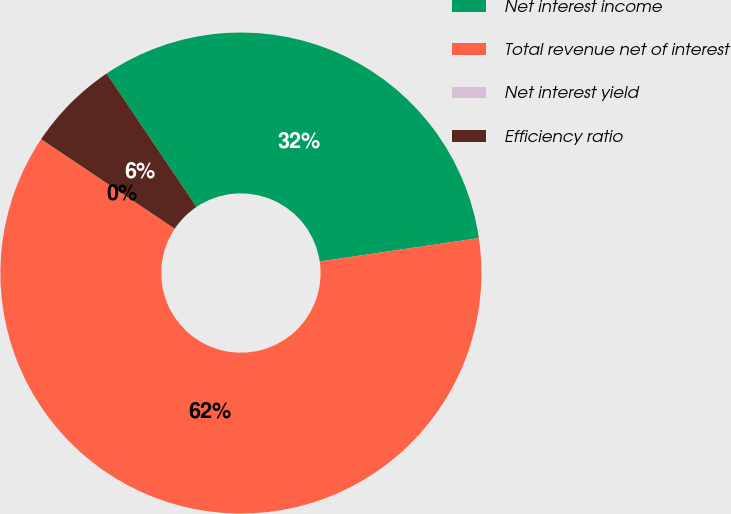Convert chart to OTSL. <chart><loc_0><loc_0><loc_500><loc_500><pie_chart><fcel>Net interest income<fcel>Total revenue net of interest<fcel>Net interest yield<fcel>Efficiency ratio<nl><fcel>32.11%<fcel>61.7%<fcel>0.01%<fcel>6.18%<nl></chart> 